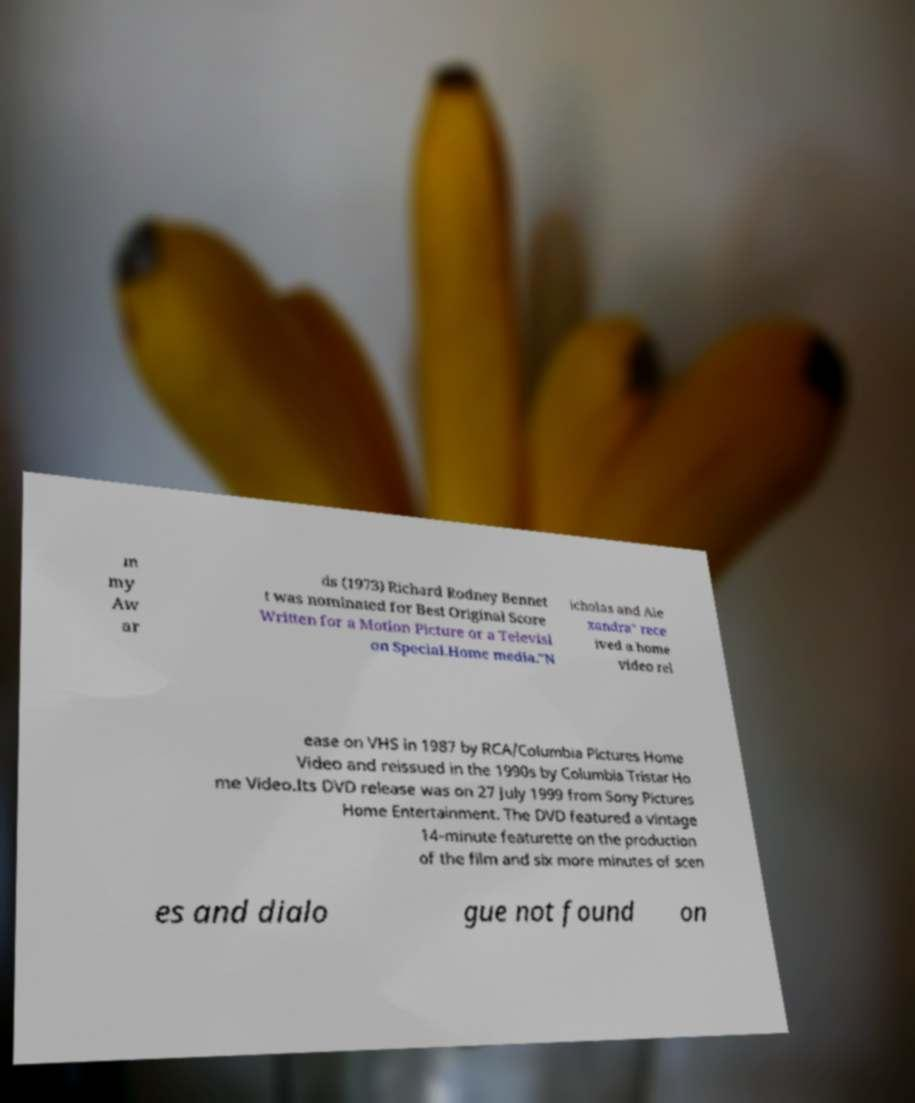What messages or text are displayed in this image? I need them in a readable, typed format. m my Aw ar ds (1973) Richard Rodney Bennet t was nominated for Best Original Score Written for a Motion Picture or a Televisi on Special.Home media."N icholas and Ale xandra" rece ived a home video rel ease on VHS in 1987 by RCA/Columbia Pictures Home Video and reissued in the 1990s by Columbia Tristar Ho me Video.Its DVD release was on 27 July 1999 from Sony Pictures Home Entertainment. The DVD featured a vintage 14-minute featurette on the production of the film and six more minutes of scen es and dialo gue not found on 